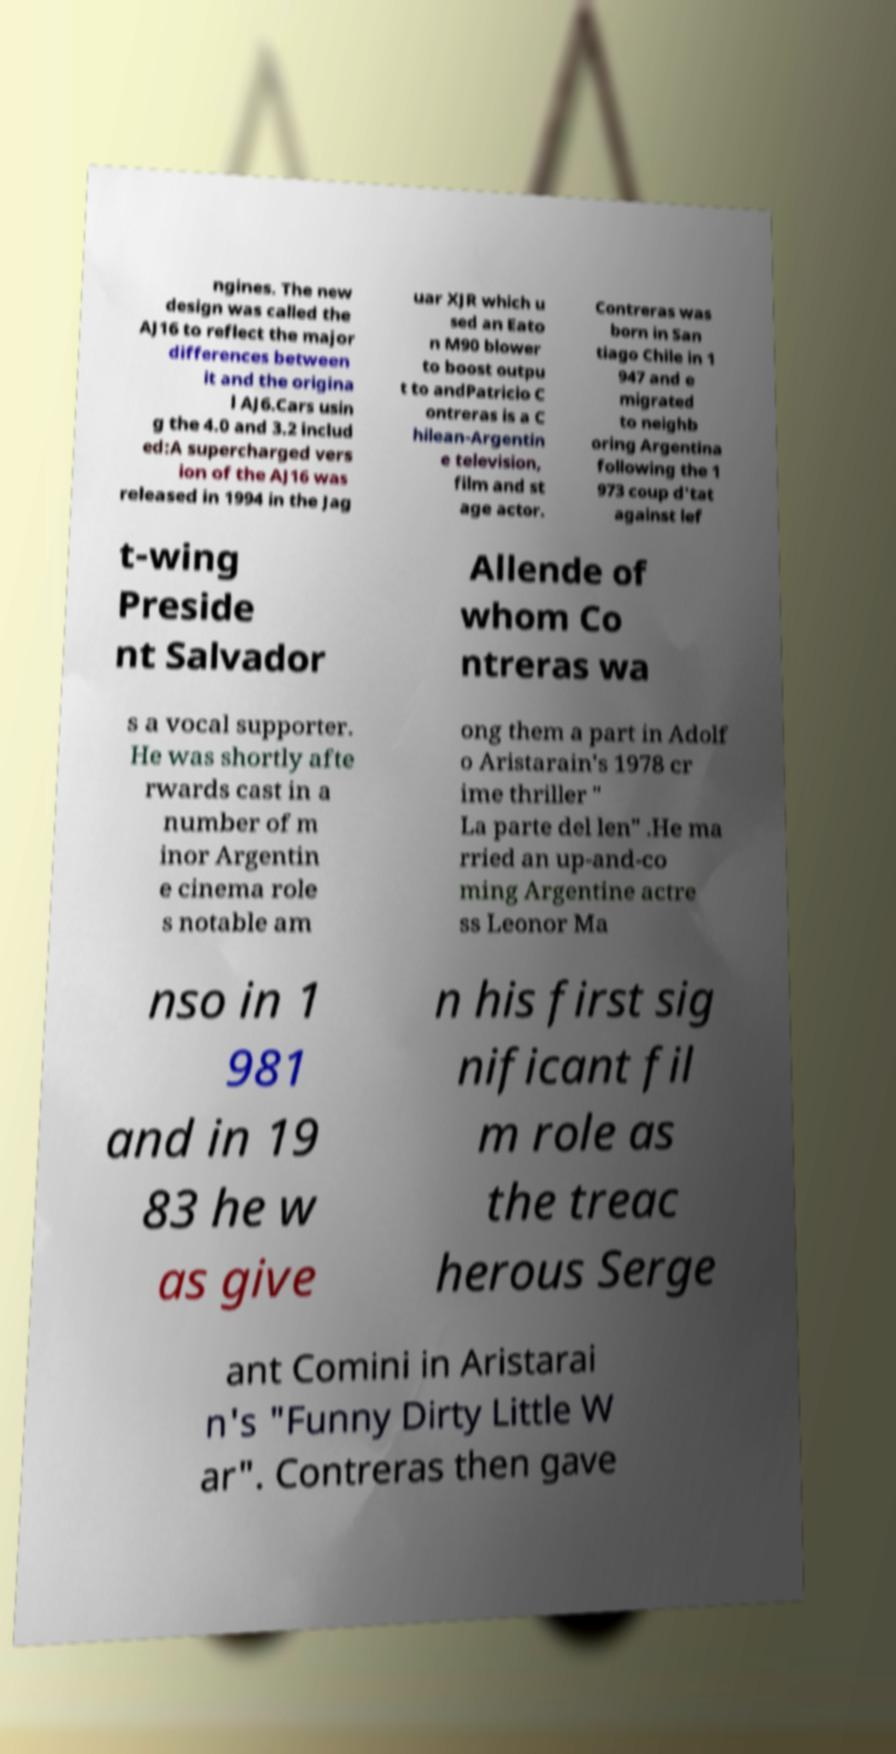Could you assist in decoding the text presented in this image and type it out clearly? ngines. The new design was called the AJ16 to reflect the major differences between it and the origina l AJ6.Cars usin g the 4.0 and 3.2 includ ed:A supercharged vers ion of the AJ16 was released in 1994 in the Jag uar XJR which u sed an Eato n M90 blower to boost outpu t to andPatricio C ontreras is a C hilean-Argentin e television, film and st age actor. Contreras was born in San tiago Chile in 1 947 and e migrated to neighb oring Argentina following the 1 973 coup d'tat against lef t-wing Preside nt Salvador Allende of whom Co ntreras wa s a vocal supporter. He was shortly afte rwards cast in a number of m inor Argentin e cinema role s notable am ong them a part in Adolf o Aristarain's 1978 cr ime thriller " La parte del len" .He ma rried an up-and-co ming Argentine actre ss Leonor Ma nso in 1 981 and in 19 83 he w as give n his first sig nificant fil m role as the treac herous Serge ant Comini in Aristarai n's "Funny Dirty Little W ar". Contreras then gave 